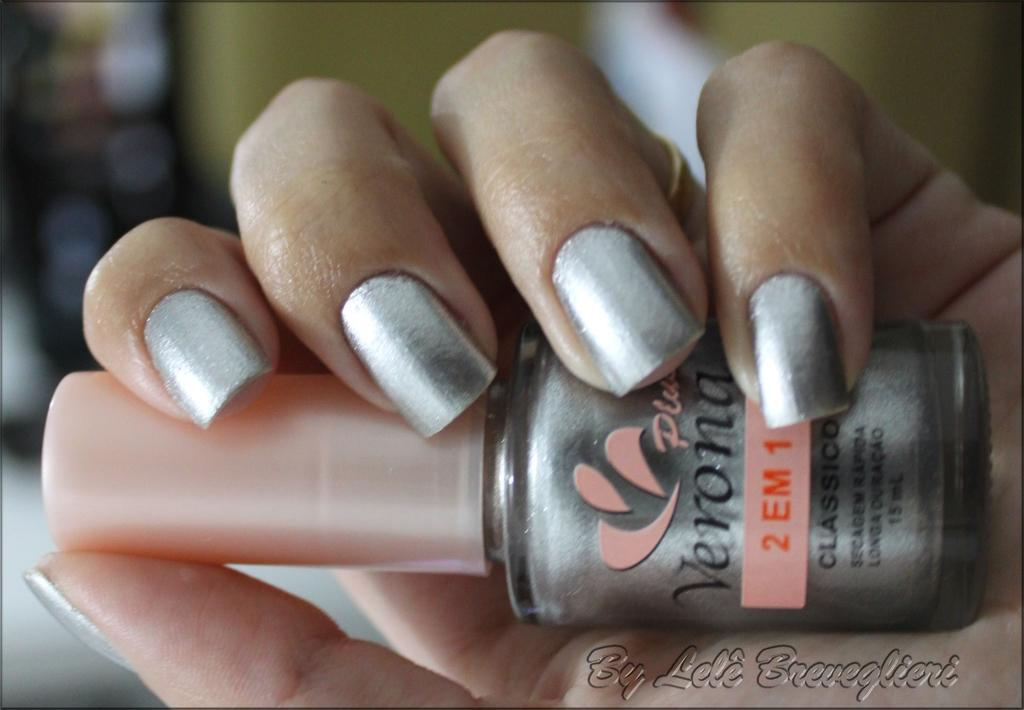What can be seen in the image that is related to personal grooming? The hand is holding a nail polish bottle in the image. Can you describe the position of the hand in the image? The hand is holding a nail polish bottle, which suggests it is likely in a position to apply the nail polish. What is written or depicted at the bottom right of the image? There is some text at the bottom right of the image. How does the marble in the image contribute to the overall aesthetic? There is no marble present in the image; it features a hand holding a nail polish bottle and some text at the bottom right. 